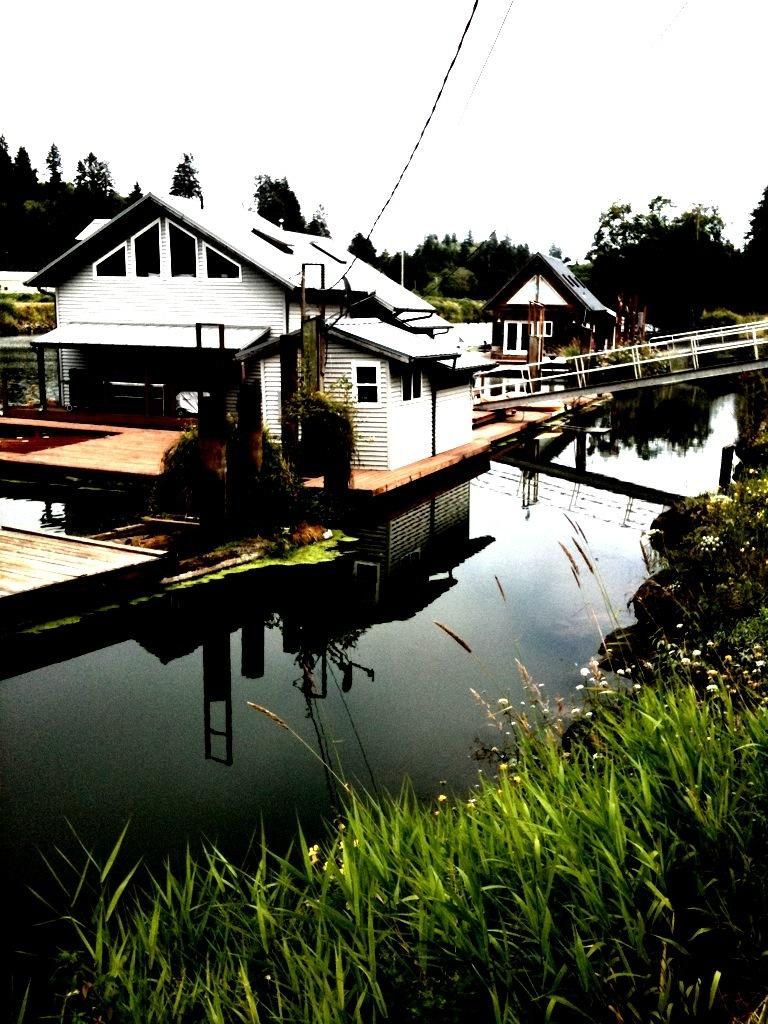What type of structure is located on the water in the image? There is a building on the water in the image. What natural element is visible in the image? There is water visible in the image. What type of vegetation can be seen in the image? There are trees and plants in the image. What scientific experiment is being conducted on the stage in the image? There is no stage or scientific experiment present in the image. 